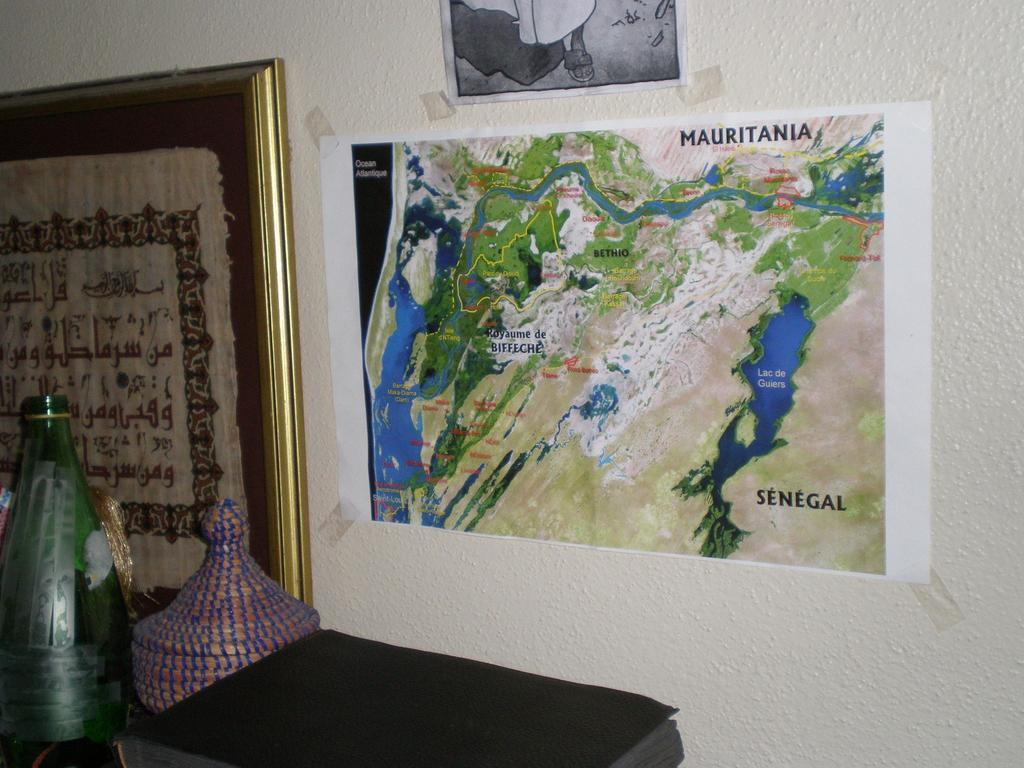What is hanging on the wall in the image? There are posters on the wall. Is there any other decorative item attached to the wall? Yes, there is a frame attached to the wall. What can be seen in front of the wall? There are objects in front of the wall. What type of glass is being used to hold the orange in the image? There is no glass or orange present in the image; it only features posters, a frame, and objects in front of the wall. 